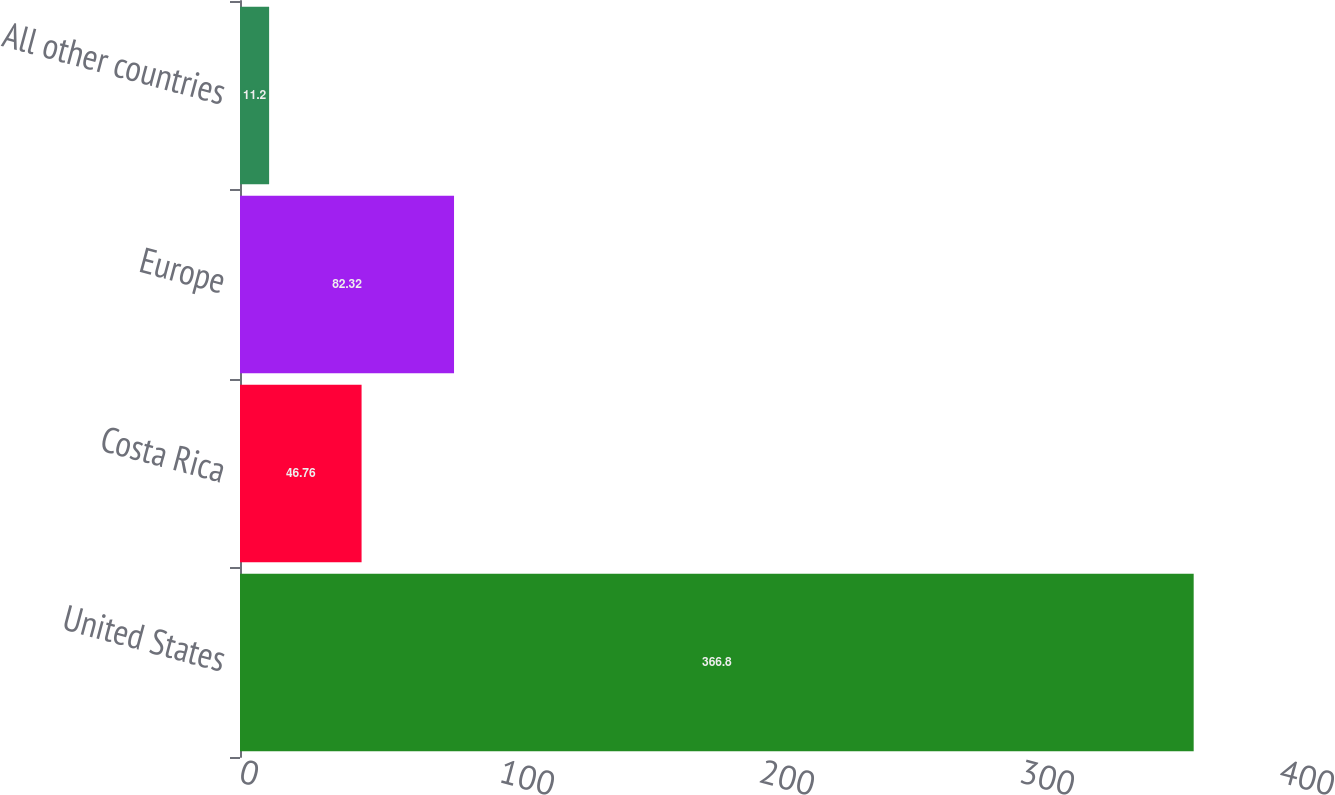Convert chart. <chart><loc_0><loc_0><loc_500><loc_500><bar_chart><fcel>United States<fcel>Costa Rica<fcel>Europe<fcel>All other countries<nl><fcel>366.8<fcel>46.76<fcel>82.32<fcel>11.2<nl></chart> 